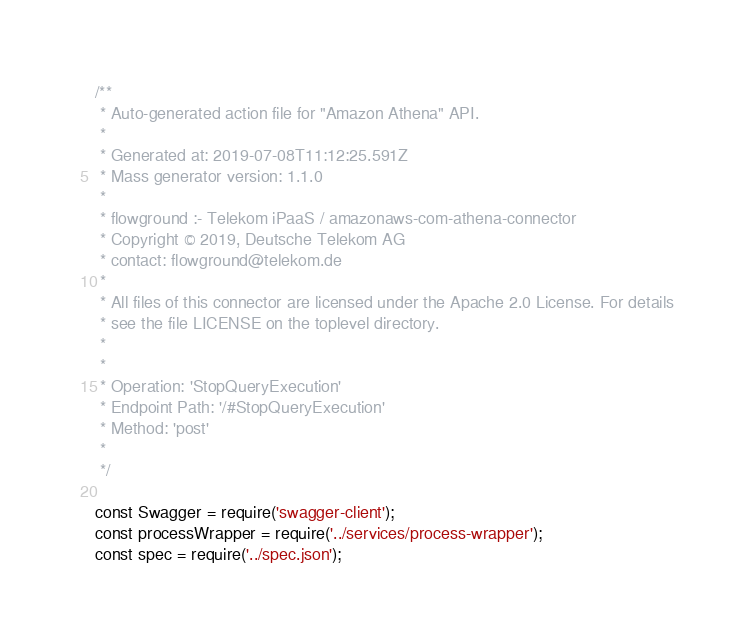<code> <loc_0><loc_0><loc_500><loc_500><_JavaScript_>/**
 * Auto-generated action file for "Amazon Athena" API.
 *
 * Generated at: 2019-07-08T11:12:25.591Z
 * Mass generator version: 1.1.0
 *
 * flowground :- Telekom iPaaS / amazonaws-com-athena-connector
 * Copyright © 2019, Deutsche Telekom AG
 * contact: flowground@telekom.de
 *
 * All files of this connector are licensed under the Apache 2.0 License. For details
 * see the file LICENSE on the toplevel directory.
 *
 *
 * Operation: 'StopQueryExecution'
 * Endpoint Path: '/#StopQueryExecution'
 * Method: 'post'
 *
 */

const Swagger = require('swagger-client');
const processWrapper = require('../services/process-wrapper');
const spec = require('../spec.json');
</code> 